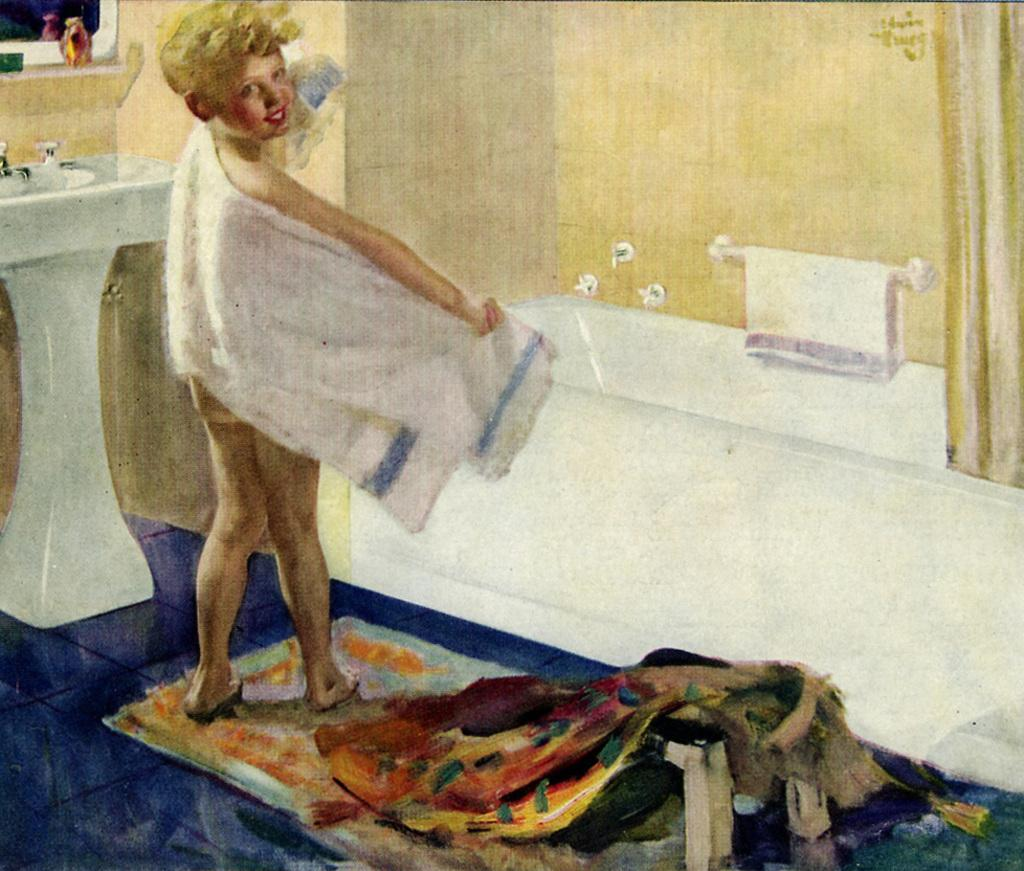What is the main subject of the image? There is a person standing in the image. What can be seen in the background of the image? There is a bathing tub and a wash basin in the image. What is on the wash basin? There are objects on the wash basin, including a towel. What is present on the floor in the image? There is a floor mat in the image. What part of the room is visible in the image? The wall is visible in the image. How many books are stacked on the person's head in the image? There are no books present in the image; the person is not holding or wearing any books. 